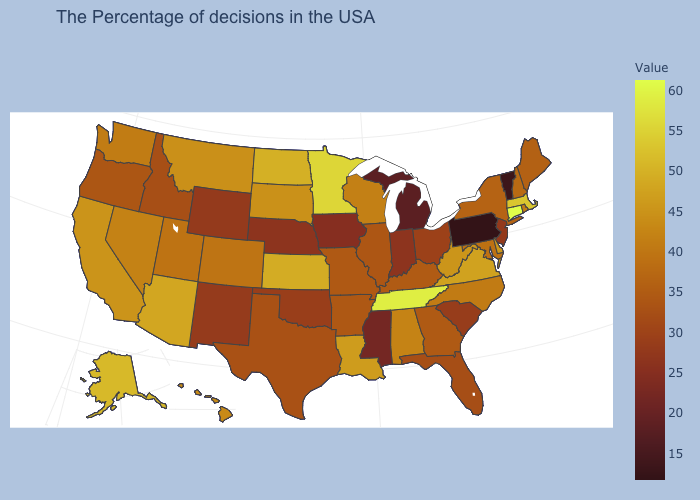Does Nevada have a higher value than Wyoming?
Keep it brief. Yes. Among the states that border New York , does Connecticut have the highest value?
Write a very short answer. Yes. Which states have the lowest value in the USA?
Concise answer only. Pennsylvania. Among the states that border Connecticut , does Rhode Island have the lowest value?
Quick response, please. No. Does the map have missing data?
Quick response, please. No. Among the states that border Louisiana , does Texas have the highest value?
Concise answer only. No. Which states have the lowest value in the USA?
Answer briefly. Pennsylvania. 